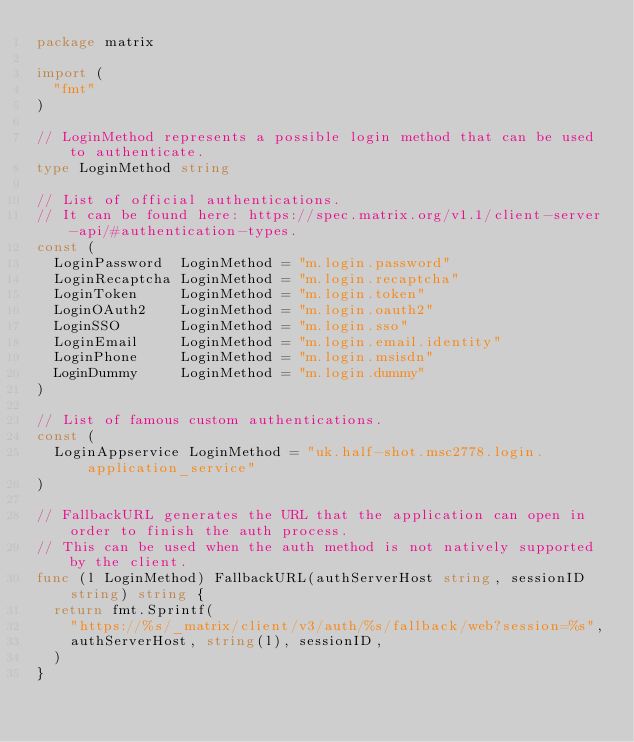<code> <loc_0><loc_0><loc_500><loc_500><_Go_>package matrix

import (
	"fmt"
)

// LoginMethod represents a possible login method that can be used to authenticate.
type LoginMethod string

// List of official authentications.
// It can be found here: https://spec.matrix.org/v1.1/client-server-api/#authentication-types.
const (
	LoginPassword  LoginMethod = "m.login.password"
	LoginRecaptcha LoginMethod = "m.login.recaptcha"
	LoginToken     LoginMethod = "m.login.token"
	LoginOAuth2    LoginMethod = "m.login.oauth2"
	LoginSSO       LoginMethod = "m.login.sso"
	LoginEmail     LoginMethod = "m.login.email.identity"
	LoginPhone     LoginMethod = "m.login.msisdn"
	LoginDummy     LoginMethod = "m.login.dummy"
)

// List of famous custom authentications.
const (
	LoginAppservice LoginMethod = "uk.half-shot.msc2778.login.application_service"
)

// FallbackURL generates the URL that the application can open in order to finish the auth process.
// This can be used when the auth method is not natively supported by the client.
func (l LoginMethod) FallbackURL(authServerHost string, sessionID string) string {
	return fmt.Sprintf(
		"https://%s/_matrix/client/v3/auth/%s/fallback/web?session=%s",
		authServerHost, string(l), sessionID,
	)
}
</code> 